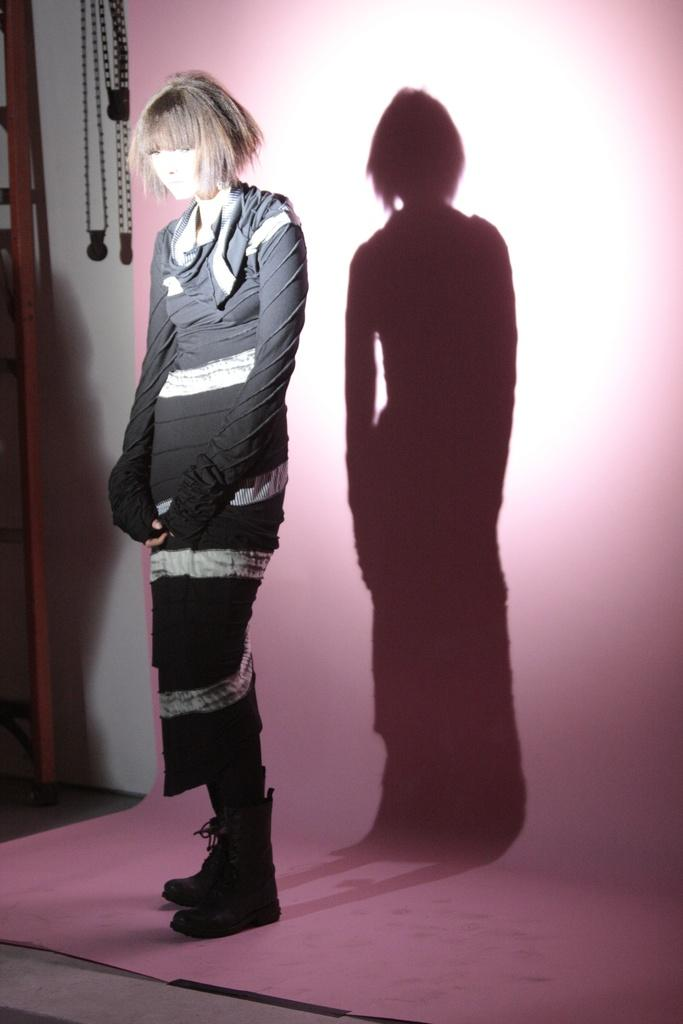What is present in the image? There is a person in the image. Can you describe the person's attire? The person is wearing clothes. What is behind the person in the image? The person is standing in front of a wall. What type of queen is depicted in the image? There is no queen depicted in the image; it features a person standing in front of a wall. What selection process is being shown in the image? There is no selection process depicted in the image; it simply shows a person standing in front of a wall. 